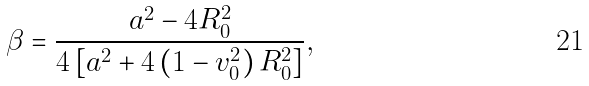Convert formula to latex. <formula><loc_0><loc_0><loc_500><loc_500>\beta = \frac { a ^ { 2 } - 4 R _ { 0 } ^ { 2 } } { 4 \left [ a ^ { 2 } + 4 \left ( 1 - v _ { 0 } ^ { 2 } \right ) R _ { 0 } ^ { 2 } \right ] } ,</formula> 